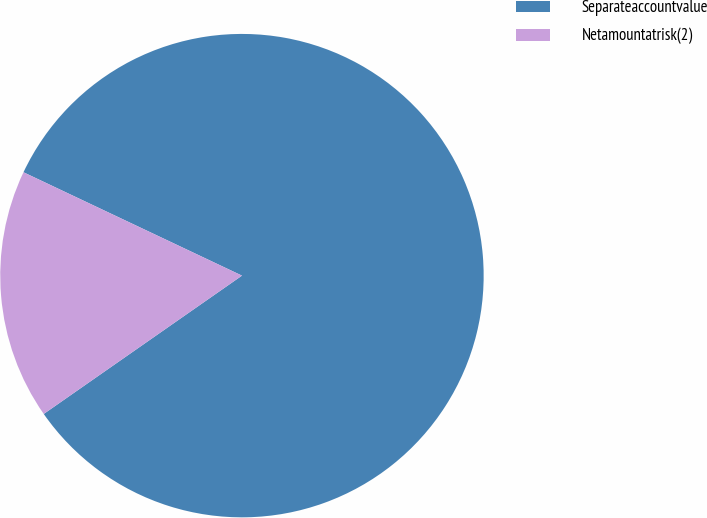Convert chart. <chart><loc_0><loc_0><loc_500><loc_500><pie_chart><fcel>Separateaccountvalue<fcel>Netamountatrisk(2)<nl><fcel>83.27%<fcel>16.73%<nl></chart> 